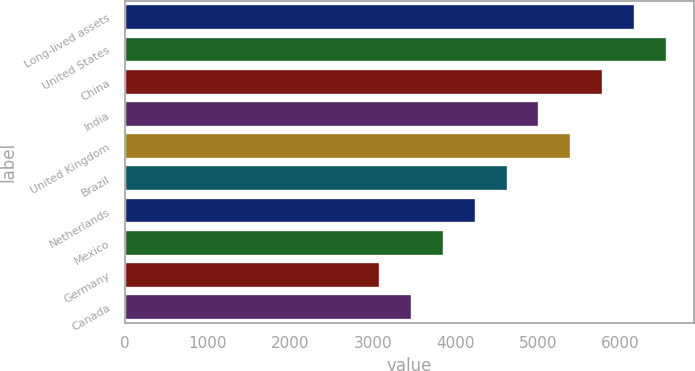Convert chart to OTSL. <chart><loc_0><loc_0><loc_500><loc_500><bar_chart><fcel>Long-lived assets<fcel>United States<fcel>China<fcel>India<fcel>United Kingdom<fcel>Brazil<fcel>Netherlands<fcel>Mexico<fcel>Germany<fcel>Canada<nl><fcel>6173.8<fcel>6559.1<fcel>5788.5<fcel>5017.9<fcel>5403.2<fcel>4632.6<fcel>4247.3<fcel>3862<fcel>3091.4<fcel>3476.7<nl></chart> 